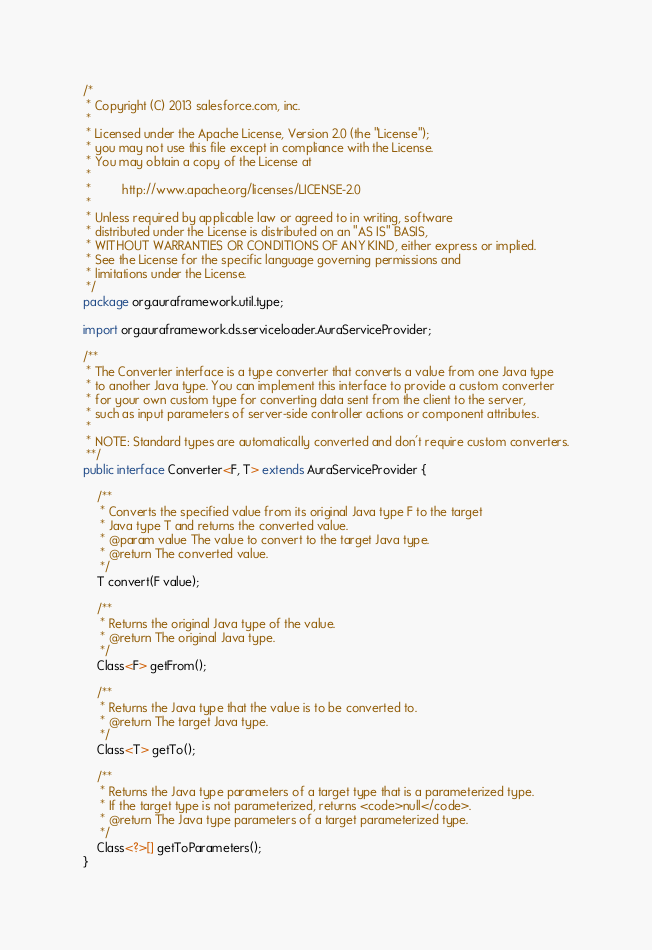<code> <loc_0><loc_0><loc_500><loc_500><_Java_>/*
 * Copyright (C) 2013 salesforce.com, inc.
 *
 * Licensed under the Apache License, Version 2.0 (the "License");
 * you may not use this file except in compliance with the License.
 * You may obtain a copy of the License at
 *
 *         http://www.apache.org/licenses/LICENSE-2.0
 *
 * Unless required by applicable law or agreed to in writing, software
 * distributed under the License is distributed on an "AS IS" BASIS,
 * WITHOUT WARRANTIES OR CONDITIONS OF ANY KIND, either express or implied.
 * See the License for the specific language governing permissions and
 * limitations under the License.
 */
package org.auraframework.util.type;

import org.auraframework.ds.serviceloader.AuraServiceProvider;

/**
 * The Converter interface is a type converter that converts a value from one Java type 
 * to another Java type. You can implement this interface to provide a custom converter 
 * for your own custom type for converting data sent from the client to the server, 
 * such as input parameters of server-side controller actions or component attributes.
 * 
 * NOTE: Standard types are automatically converted and don't require custom converters.
 **/
public interface Converter<F, T> extends AuraServiceProvider {

    /**
     * Converts the specified value from its original Java type F to the target 
     * Java type T and returns the converted value.
     * @param value The value to convert to the target Java type.
     * @return The converted value.
     */
    T convert(F value);

    /**
     * Returns the original Java type of the value.
     * @return The original Java type.
     */
    Class<F> getFrom();

    /**
     * Returns the Java type that the value is to be converted to.
     * @return The target Java type.
     */
    Class<T> getTo();

    /**
     * Returns the Java type parameters of a target type that is a parameterized type. 
     * If the target type is not parameterized, returns <code>null</code>.
     * @return The Java type parameters of a target parameterized type.
     */
    Class<?>[] getToParameters();
}
</code> 